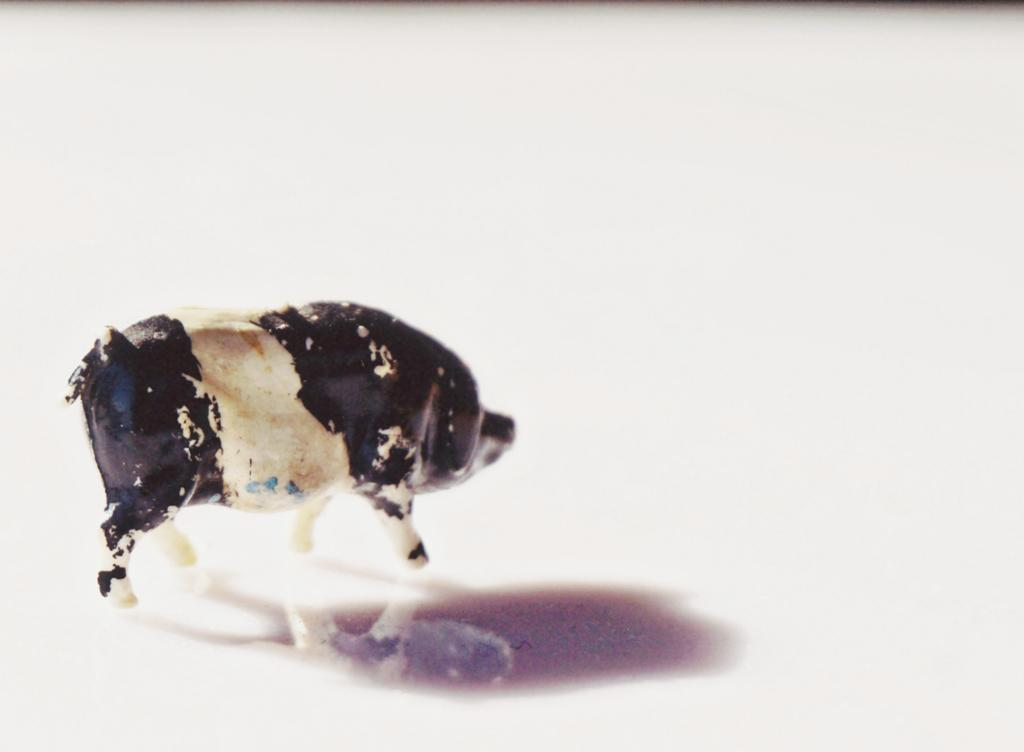What object can be seen in the image? There is a toy in the image. What is the color of the surface on which the toy is placed? The toy is on a white surface. Reasoning: Let' Let's think step by step in order to produce the conversation. We start by identifying the main subject in the image, which is the toy. Then, we expand the conversation to include the color of the surface on which the toy is placed. Each question is designed to elicit a specific detail about the image that is known from the provided facts. Absurd Question/Answer: What type of celery is being used to control the toy in the image? There is no celery present in the image, and the toy is not being controlled by any external object. 